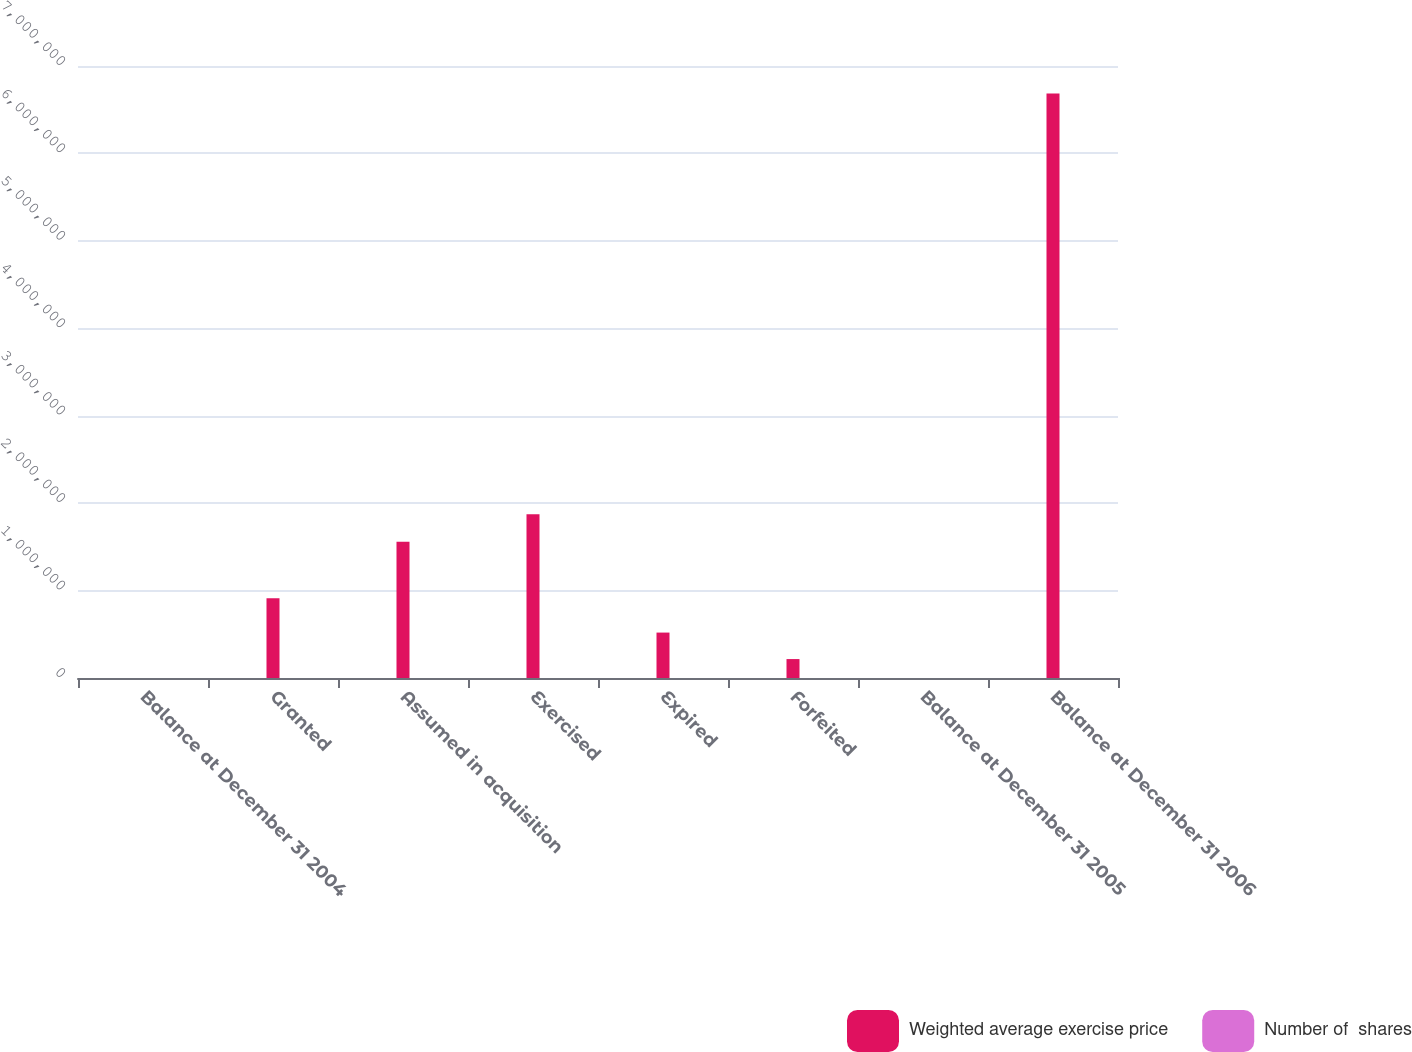Convert chart. <chart><loc_0><loc_0><loc_500><loc_500><stacked_bar_chart><ecel><fcel>Balance at December 31 2004<fcel>Granted<fcel>Assumed in acquisition<fcel>Exercised<fcel>Expired<fcel>Forfeited<fcel>Balance at December 31 2005<fcel>Balance at December 31 2006<nl><fcel>Weighted average exercise price<fcel>68.95<fcel>912905<fcel>1.55969e+06<fcel>1.87275e+06<fcel>519521<fcel>216533<fcel>68.95<fcel>6.68679e+06<nl><fcel>Number of  shares<fcel>51.98<fcel>71.37<fcel>47.44<fcel>50<fcel>66.53<fcel>55.46<fcel>52.79<fcel>57.62<nl></chart> 